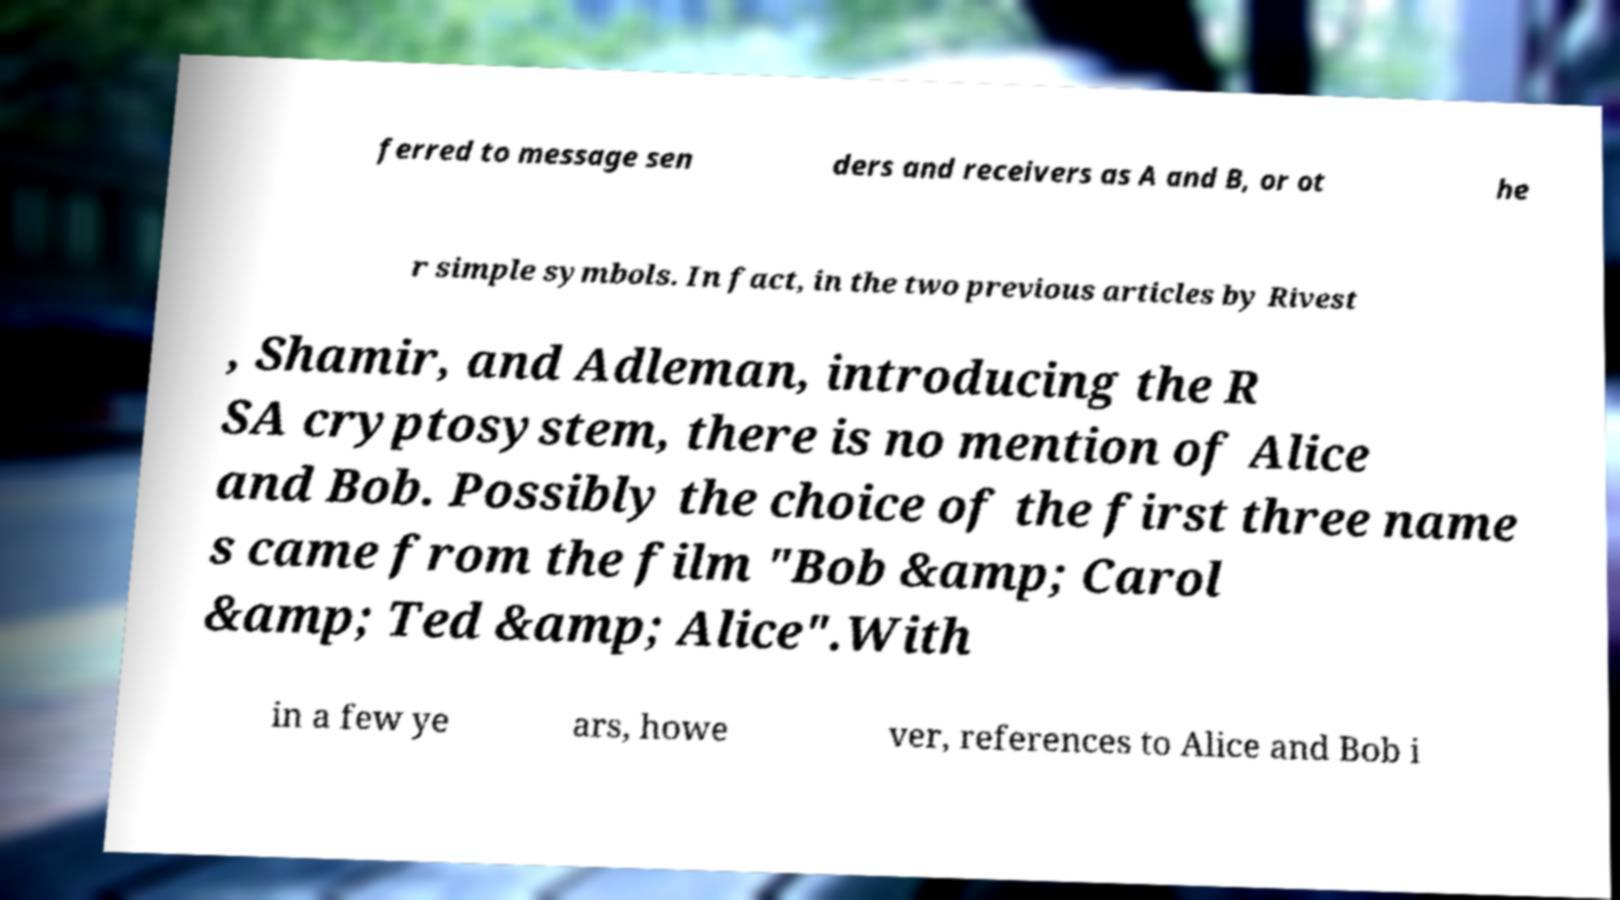Can you read and provide the text displayed in the image?This photo seems to have some interesting text. Can you extract and type it out for me? ferred to message sen ders and receivers as A and B, or ot he r simple symbols. In fact, in the two previous articles by Rivest , Shamir, and Adleman, introducing the R SA cryptosystem, there is no mention of Alice and Bob. Possibly the choice of the first three name s came from the film "Bob &amp; Carol &amp; Ted &amp; Alice".With in a few ye ars, howe ver, references to Alice and Bob i 